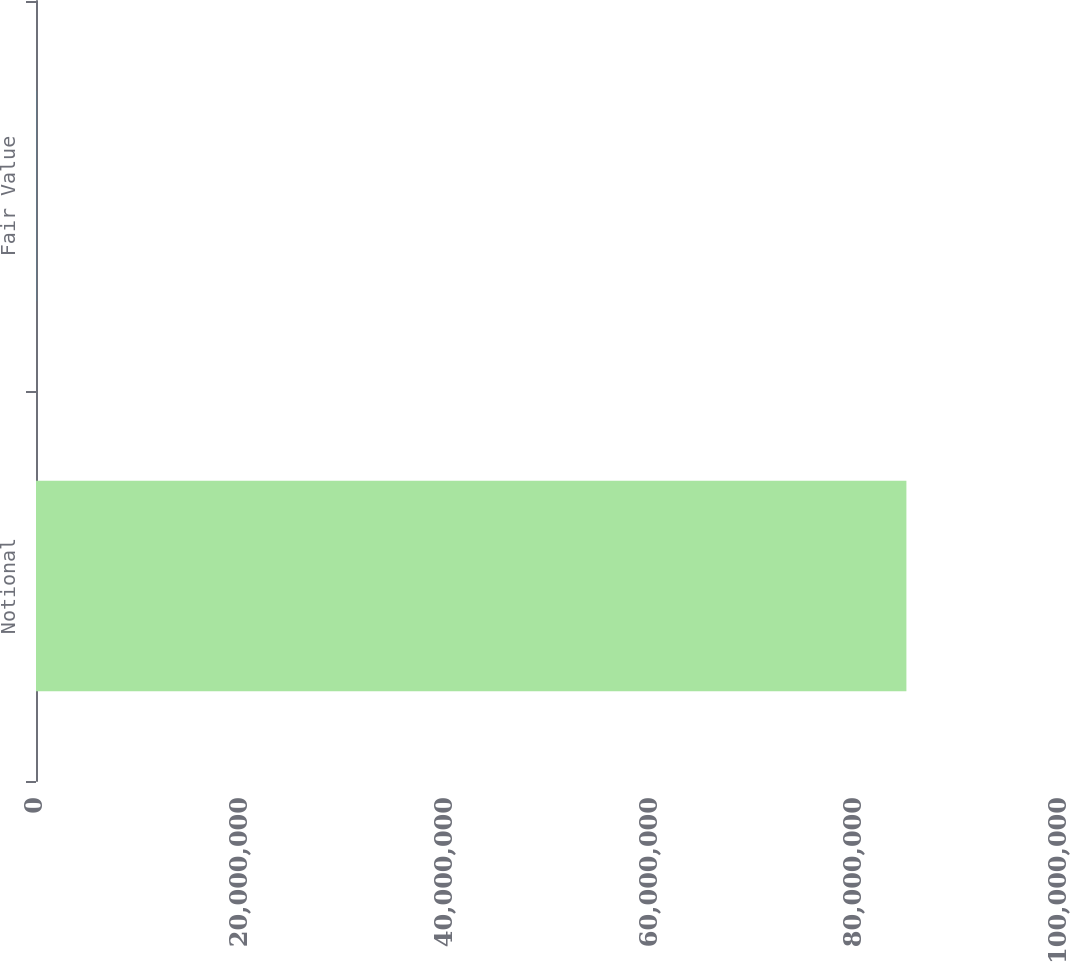Convert chart to OTSL. <chart><loc_0><loc_0><loc_500><loc_500><bar_chart><fcel>Notional<fcel>Fair Value<nl><fcel>8.5e+07<fcel>8763<nl></chart> 